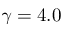<formula> <loc_0><loc_0><loc_500><loc_500>\gamma = 4 . 0</formula> 